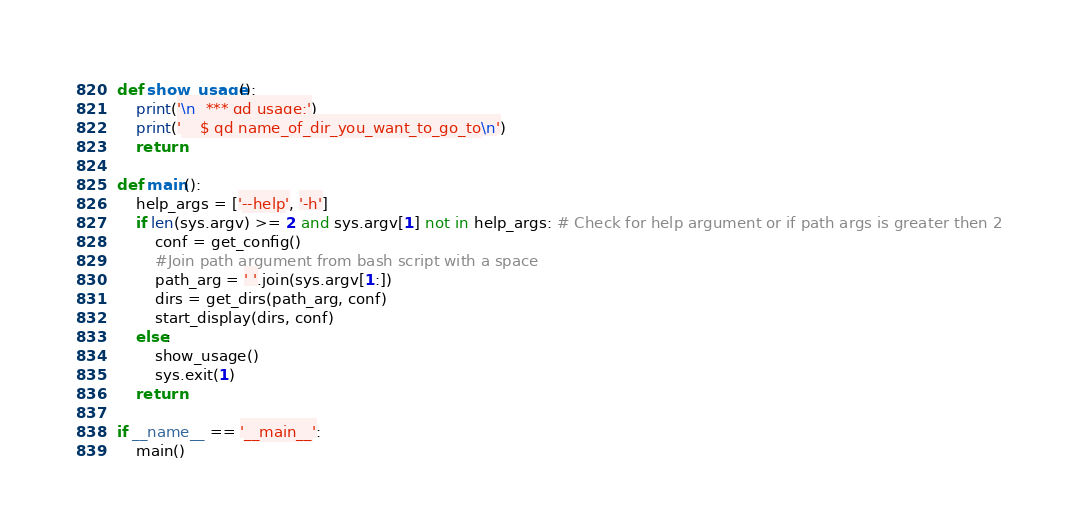<code> <loc_0><loc_0><loc_500><loc_500><_Python_>def show_usage():
    print('\n  *** qd usage:')
    print('    $ qd name_of_dir_you_want_to_go_to\n')
    return

def main():
    help_args = ['--help', '-h']
    if len(sys.argv) >= 2 and sys.argv[1] not in help_args: # Check for help argument or if path args is greater then 2
        conf = get_config()
        #Join path argument from bash script with a space
        path_arg = ' '.join(sys.argv[1:])
        dirs = get_dirs(path_arg, conf)
        start_display(dirs, conf)
    else:
        show_usage()
        sys.exit(1)
    return

if __name__ == '__main__':
    main()
</code> 